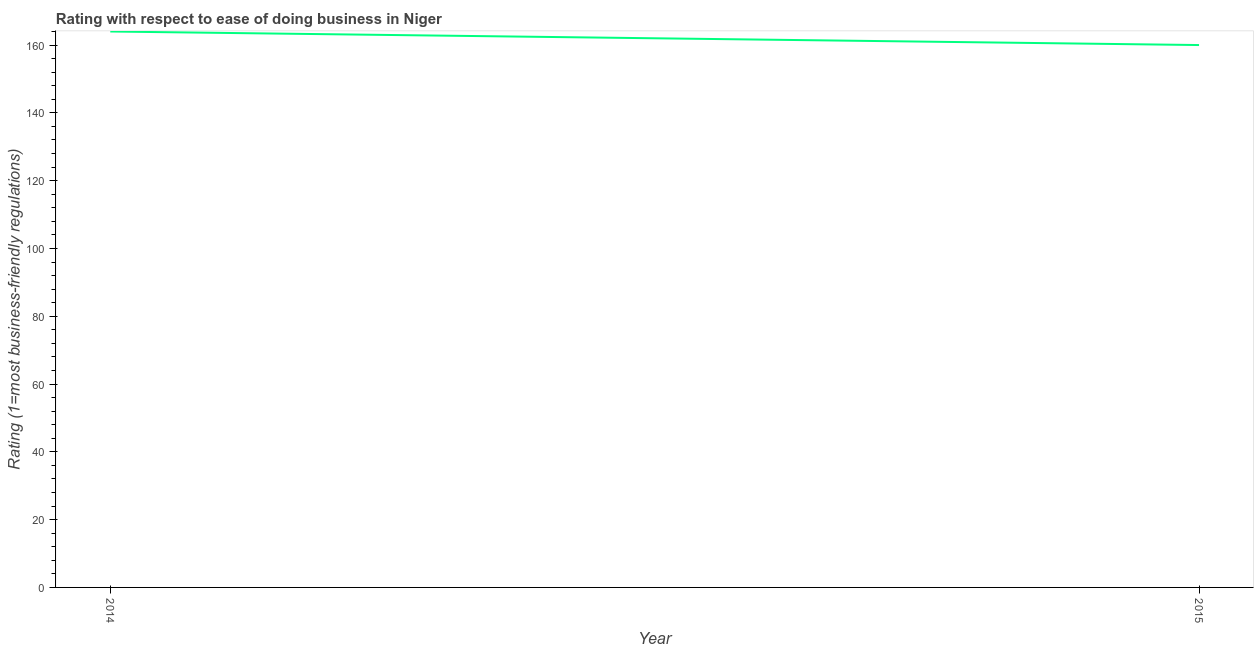What is the ease of doing business index in 2014?
Offer a terse response. 164. Across all years, what is the maximum ease of doing business index?
Keep it short and to the point. 164. Across all years, what is the minimum ease of doing business index?
Your answer should be compact. 160. In which year was the ease of doing business index maximum?
Ensure brevity in your answer.  2014. In which year was the ease of doing business index minimum?
Your answer should be compact. 2015. What is the sum of the ease of doing business index?
Ensure brevity in your answer.  324. What is the difference between the ease of doing business index in 2014 and 2015?
Your answer should be very brief. 4. What is the average ease of doing business index per year?
Provide a succinct answer. 162. What is the median ease of doing business index?
Make the answer very short. 162. What is the ratio of the ease of doing business index in 2014 to that in 2015?
Your response must be concise. 1.02. Is the ease of doing business index in 2014 less than that in 2015?
Ensure brevity in your answer.  No. Does the ease of doing business index monotonically increase over the years?
Ensure brevity in your answer.  No. How many lines are there?
Offer a very short reply. 1. How many years are there in the graph?
Provide a succinct answer. 2. What is the title of the graph?
Keep it short and to the point. Rating with respect to ease of doing business in Niger. What is the label or title of the X-axis?
Keep it short and to the point. Year. What is the label or title of the Y-axis?
Your answer should be compact. Rating (1=most business-friendly regulations). What is the Rating (1=most business-friendly regulations) in 2014?
Give a very brief answer. 164. What is the Rating (1=most business-friendly regulations) in 2015?
Offer a very short reply. 160. What is the ratio of the Rating (1=most business-friendly regulations) in 2014 to that in 2015?
Your answer should be compact. 1.02. 